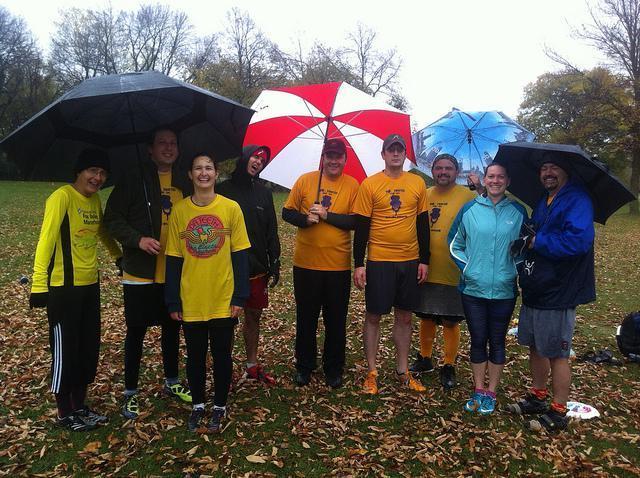How many people are in yellow shirts?
Give a very brief answer. 3. How many umbrellas are in the design of an animal?
Give a very brief answer. 0. How many black umbrellas are shown?
Give a very brief answer. 2. How many people are there?
Give a very brief answer. 9. How many umbrellas are in the photo?
Give a very brief answer. 4. 